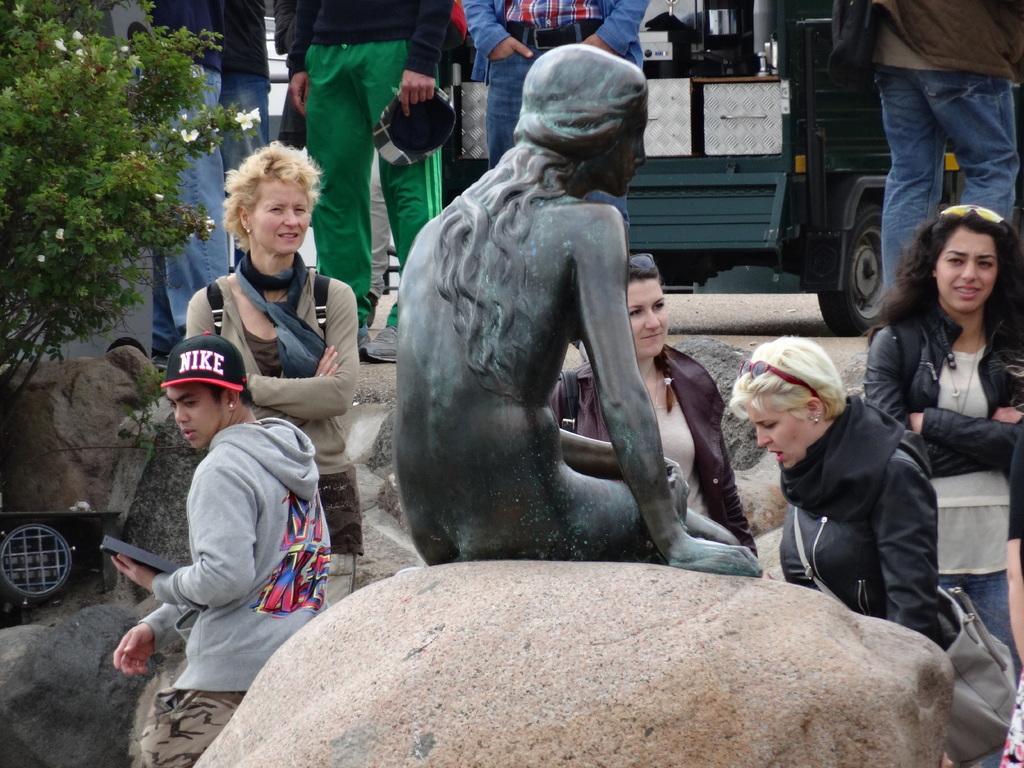Describe this image in one or two sentences. In this picture we can observe a statue of a woman which is in black color, on the rock. There are some people in this picture. We can observe men and women. On the left side there is a small tree. In the background we can observe a vehicle. 